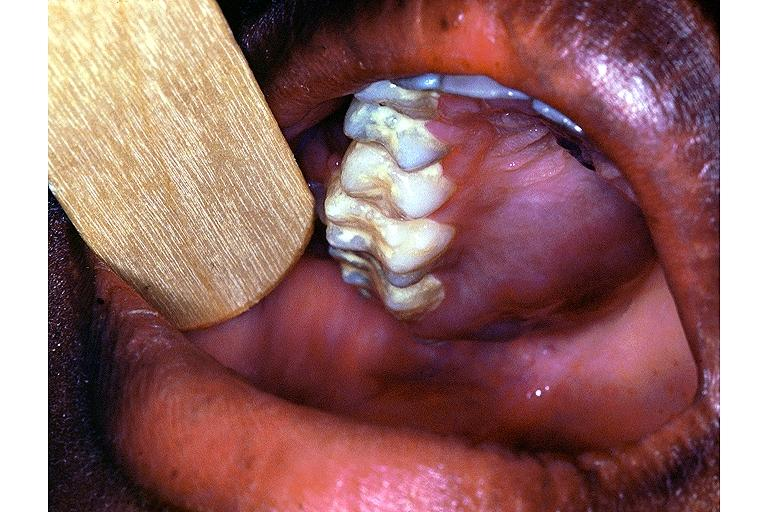s oral present?
Answer the question using a single word or phrase. Yes 